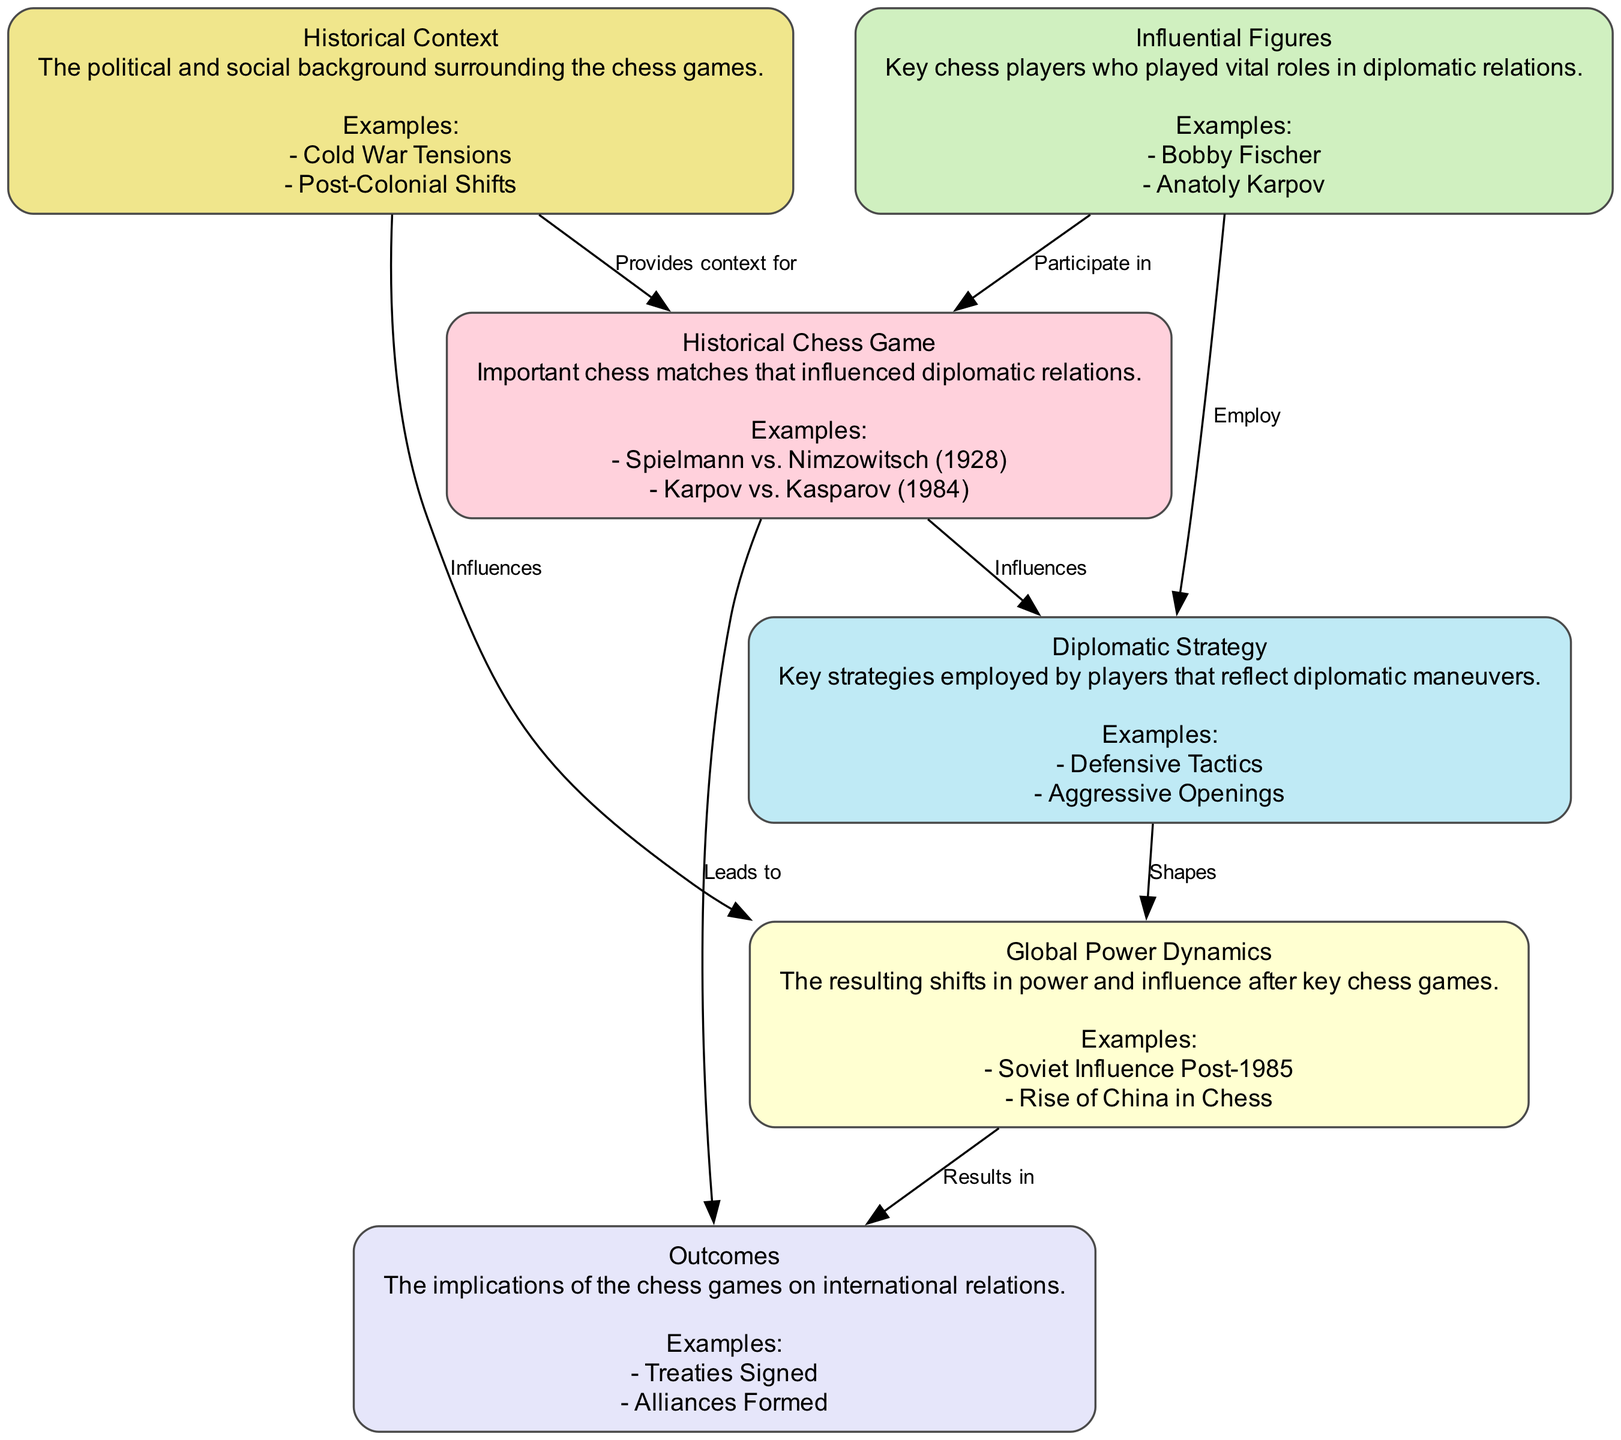What is the primary focus of the diagram? The primary focus of the diagram is to analyze how diplomatic strategies in historical chess games influence global power dynamics. This is evident from the main nodes and the connections between them, particularly how they culminate in various outcomes.
Answer: Analysis of Diplomatic Strategies in Historical Chess Games How many elements are represented in the diagram? The diagram features six elements, as described in the provided data. Each element represents a different aspect related to the analysis of diplomatic strategies in chess games.
Answer: Six What influences Diplomatic Strategy according to the diagram? According to the diagram, Historical Chess Game influences Diplomatic Strategy. This is indicated by the arrow showing the directional influence from game history to the strategies employed in those games.
Answer: Historical Chess Game Which historical chess game is cited as an example in the Influential Figures category? In the Influential Figures category, 'Bobby Fischer' is cited as an example. This is explicitly mentioned under the corresponding element in the diagram.
Answer: Bobby Fischer What is the relationship between Historical Context and Historical Chess Game? The relationship is that Historical Context provides context for Historical Chess Game. This can be seen from the edge connecting these two elements, indicating a supportive role of the historical environment in understanding the chess matches.
Answer: Provides context for Which two elements are connected by the edge labeled 'Results in'? The edge labeled 'Results in' connects Global Power Dynamics to Outcomes. This indicates the implication of shifts in power and their resulting effects on international relations after key chess games.
Answer: Global Power Dynamics and Outcomes How do Influential Figures engage with Historical Chess Games? Influential Figures participate in Historical Chess Games, as indicated by the directed edge connecting these two categories in the diagram. This implies that significant chess players influence the dynamics of the games they play.
Answer: Participate in What type of outcomes does the diagram suggest are a result of chess games? The diagram suggests that outcomes such as treaties signed and alliances formed are the results of chess games. This is indicated as the concluding implications of the games, showcasing a direct impact on international relations.
Answer: Treaties Signed, Alliances Formed What role do Diplomatic Strategies play in shaping Global Power Dynamics? Diplomatic Strategies shape Global Power Dynamics, which implies that the strategies employed by chess players have a significant bearing on the overall shifts of influence and power in the geopolitical landscape.
Answer: Shapes 